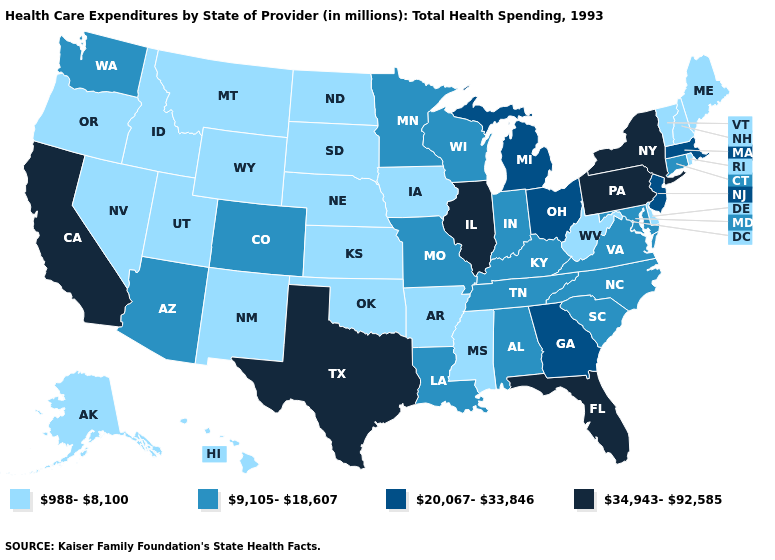What is the value of Mississippi?
Give a very brief answer. 988-8,100. Name the states that have a value in the range 9,105-18,607?
Answer briefly. Alabama, Arizona, Colorado, Connecticut, Indiana, Kentucky, Louisiana, Maryland, Minnesota, Missouri, North Carolina, South Carolina, Tennessee, Virginia, Washington, Wisconsin. Among the states that border Kentucky , does Illinois have the highest value?
Give a very brief answer. Yes. Name the states that have a value in the range 34,943-92,585?
Write a very short answer. California, Florida, Illinois, New York, Pennsylvania, Texas. What is the highest value in the Northeast ?
Concise answer only. 34,943-92,585. What is the value of Arizona?
Short answer required. 9,105-18,607. Does Vermont have the lowest value in the Northeast?
Give a very brief answer. Yes. Does North Carolina have the lowest value in the South?
Answer briefly. No. Which states have the lowest value in the MidWest?
Quick response, please. Iowa, Kansas, Nebraska, North Dakota, South Dakota. Does Texas have the highest value in the USA?
Answer briefly. Yes. What is the highest value in states that border New Jersey?
Give a very brief answer. 34,943-92,585. Which states have the highest value in the USA?
Give a very brief answer. California, Florida, Illinois, New York, Pennsylvania, Texas. What is the value of Virginia?
Give a very brief answer. 9,105-18,607. Does Georgia have a higher value than Michigan?
Quick response, please. No. Does Kentucky have the lowest value in the USA?
Short answer required. No. 